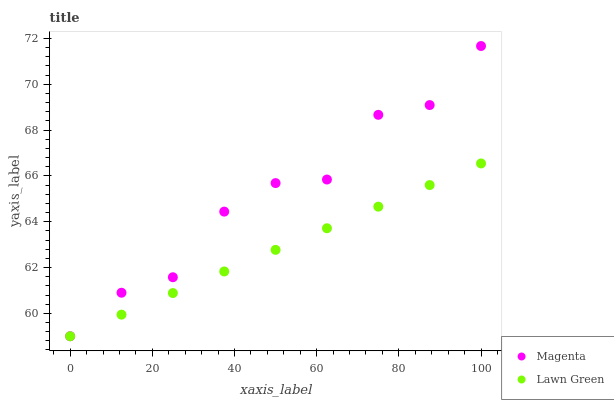Does Lawn Green have the minimum area under the curve?
Answer yes or no. Yes. Does Magenta have the maximum area under the curve?
Answer yes or no. Yes. Does Magenta have the minimum area under the curve?
Answer yes or no. No. Is Lawn Green the smoothest?
Answer yes or no. Yes. Is Magenta the roughest?
Answer yes or no. Yes. Is Magenta the smoothest?
Answer yes or no. No. Does Lawn Green have the lowest value?
Answer yes or no. Yes. Does Magenta have the highest value?
Answer yes or no. Yes. Does Lawn Green intersect Magenta?
Answer yes or no. Yes. Is Lawn Green less than Magenta?
Answer yes or no. No. Is Lawn Green greater than Magenta?
Answer yes or no. No. 